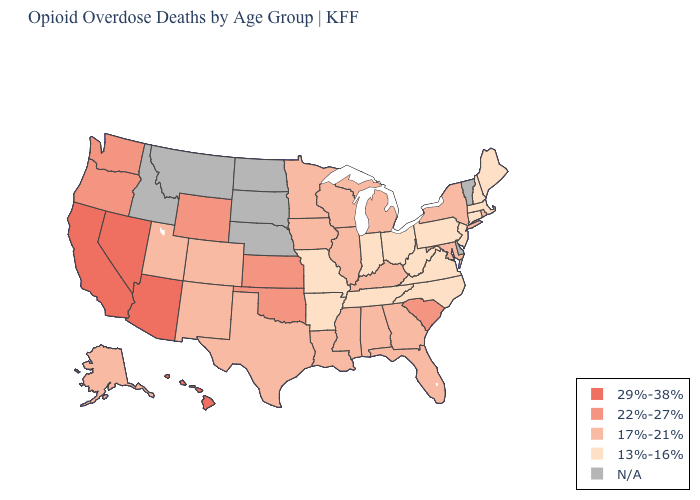What is the lowest value in states that border Maine?
Keep it brief. 13%-16%. What is the value of Louisiana?
Short answer required. 17%-21%. Is the legend a continuous bar?
Write a very short answer. No. Name the states that have a value in the range 22%-27%?
Concise answer only. Kansas, Oklahoma, Oregon, South Carolina, Washington, Wyoming. What is the highest value in the MidWest ?
Quick response, please. 22%-27%. Name the states that have a value in the range 13%-16%?
Quick response, please. Arkansas, Connecticut, Indiana, Maine, Massachusetts, Missouri, New Hampshire, New Jersey, North Carolina, Ohio, Pennsylvania, Tennessee, Virginia, West Virginia. Which states have the lowest value in the USA?
Quick response, please. Arkansas, Connecticut, Indiana, Maine, Massachusetts, Missouri, New Hampshire, New Jersey, North Carolina, Ohio, Pennsylvania, Tennessee, Virginia, West Virginia. Which states hav the highest value in the South?
Short answer required. Oklahoma, South Carolina. Among the states that border Florida , which have the highest value?
Concise answer only. Alabama, Georgia. Which states have the lowest value in the USA?
Keep it brief. Arkansas, Connecticut, Indiana, Maine, Massachusetts, Missouri, New Hampshire, New Jersey, North Carolina, Ohio, Pennsylvania, Tennessee, Virginia, West Virginia. What is the lowest value in the USA?
Be succinct. 13%-16%. What is the highest value in the USA?
Keep it brief. 29%-38%. Name the states that have a value in the range 29%-38%?
Concise answer only. Arizona, California, Hawaii, Nevada. Does Iowa have the highest value in the MidWest?
Write a very short answer. No. 